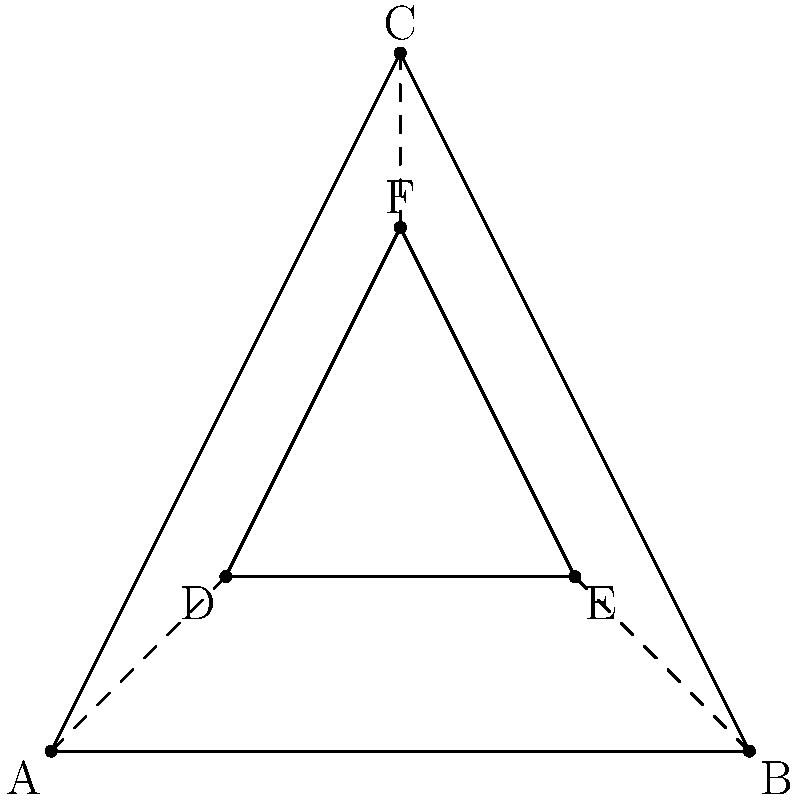Given the triangular representation of a trilobite fossil as shown in the diagram, with an outer triangle ABC and an inner triangle DEF, determine the group of symmetries for this structure. What is the order of this group? To determine the group of symmetries for this trilobite fossil representation, we need to analyze the transformations that leave the structure unchanged:

1. Identity transformation: This always exists for any structure.

2. Rotational symmetry: The structure has 3-fold rotational symmetry (rotations of 120° and 240° around the center).

3. Reflection symmetry: There are three lines of reflection symmetry, passing through each vertex and the midpoint of the opposite side.

These symmetries form the dihedral group $D_3$, which is the group of symmetries of an equilateral triangle. To find the order of this group:

1. Count the number of rotations: 3 (including the identity)
2. Count the number of reflections: 3

The total number of symmetries (order of the group) is the sum of rotations and reflections:

$$ |D_3| = 3 + 3 = 6 $$

Therefore, the group of symmetries for this trilobite fossil representation is $D_3$, and its order is 6.
Answer: $D_3$, order 6 